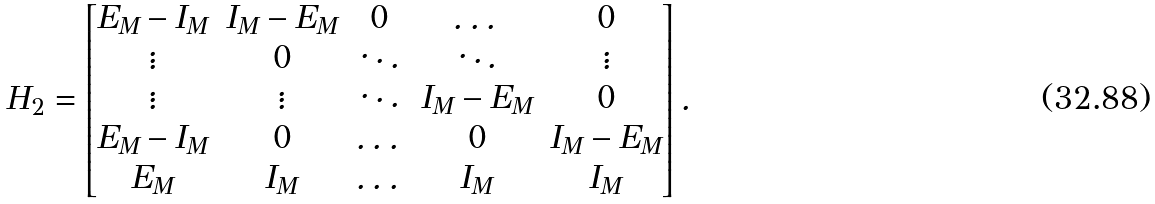Convert formula to latex. <formula><loc_0><loc_0><loc_500><loc_500>H _ { 2 } = \begin{bmatrix} E _ { M } - I _ { M } & I _ { M } - E _ { M } & 0 & \dots & 0 \\ \vdots & 0 & \ddots & \ddots & \vdots \\ \vdots & \vdots & \ddots & I _ { M } - E _ { M } & 0 \\ E _ { M } - I _ { M } & 0 & \dots & 0 & I _ { M } - E _ { M } \\ E _ { M } & I _ { M } & \dots & I _ { M } & I _ { M } \end{bmatrix} .</formula> 